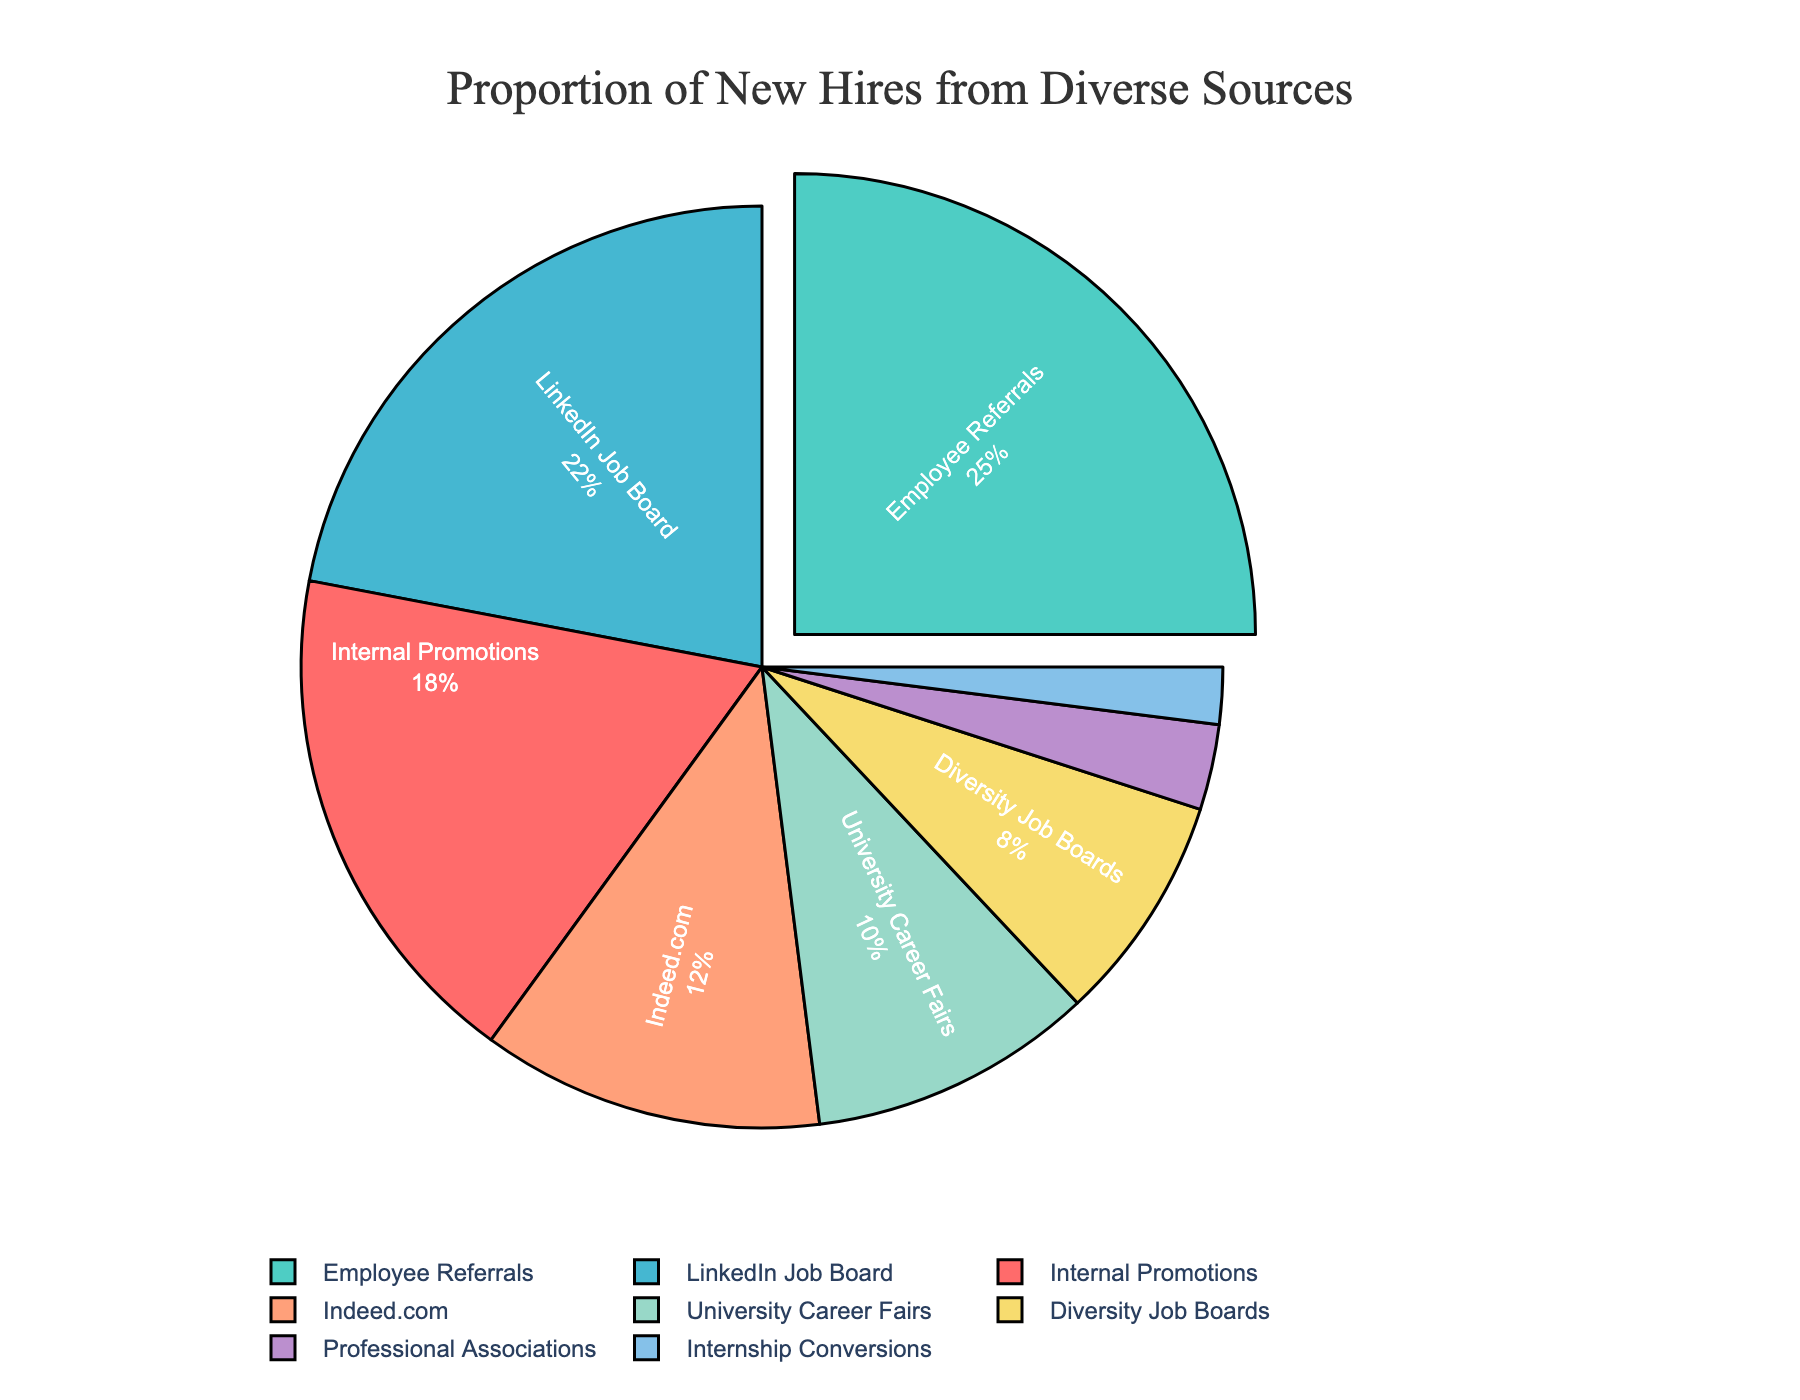What's the proportion of new hires from Employee Referrals? Look for the "Employee Referrals" slice in the pie chart and read the percent value displayed on it.
Answer: 25% Which source has the highest proportion of new hires, and what is its percentage? Identify the slice that's pulled out from the pie chart, which visually represents the highest percentage. Check the label and percentage displayed.
Answer: Employee Referrals, 25% What is the combined percentage of new hires from LinkedIn Job Board and Indeed.com? Locate the "LinkedIn Job Board" and "Indeed.com" slices in the chart and add the two percentages together: 22% + 12% = 34%.
Answer: 34% How much larger is the proportion of new hires from Internal Promotions compared to Internship Conversions? Find the percentages for both "Internal Promotions" and "Internship Conversions": 18% and 2%, respectively. Subtract the smaller percentage from the larger one: 18% - 2% = 16%.
Answer: 16% Which sources together make up more than 50% of new hires? Sum the percentages of the largest slices until the total exceeds 50%: Employee Referrals (25%) + LinkedIn Job Board (22%) = 47%, then add Internal Promotions (18%) = 65%. Thus, together these three make more than 50%.
Answer: Employee Referrals, LinkedIn Job Board, Internal Promotions What is the visual color of the slice representing Diversity Job Boards? Identify the "Diversity Job Boards" slice in the pie chart and describe its color.
Answer: Yellow What's the difference between the proportion of new hires from Professional Associations and University Career Fairs? Identify the slices representing "Professional Associations" (3%) and "University Career Fairs" (10%), then subtract the smaller percentage from the larger one: 10% - 3% = 7%.
Answer: 7% Which source has the second-lowest proportion of new hires, and what is its percentage? List the percentages in ascending order, and the second-lowest will be Professional Associations.
Answer: Professional Associations, 3% What is the average percentage of new hires from all sources? Add up all the percentages: 18% + 25% + 22% + 12% + 10% + 8% + 3% + 2% = 100%. There are 8 sources, so the average is 100% / 8 = 12.5%.
Answer: 12.5% 